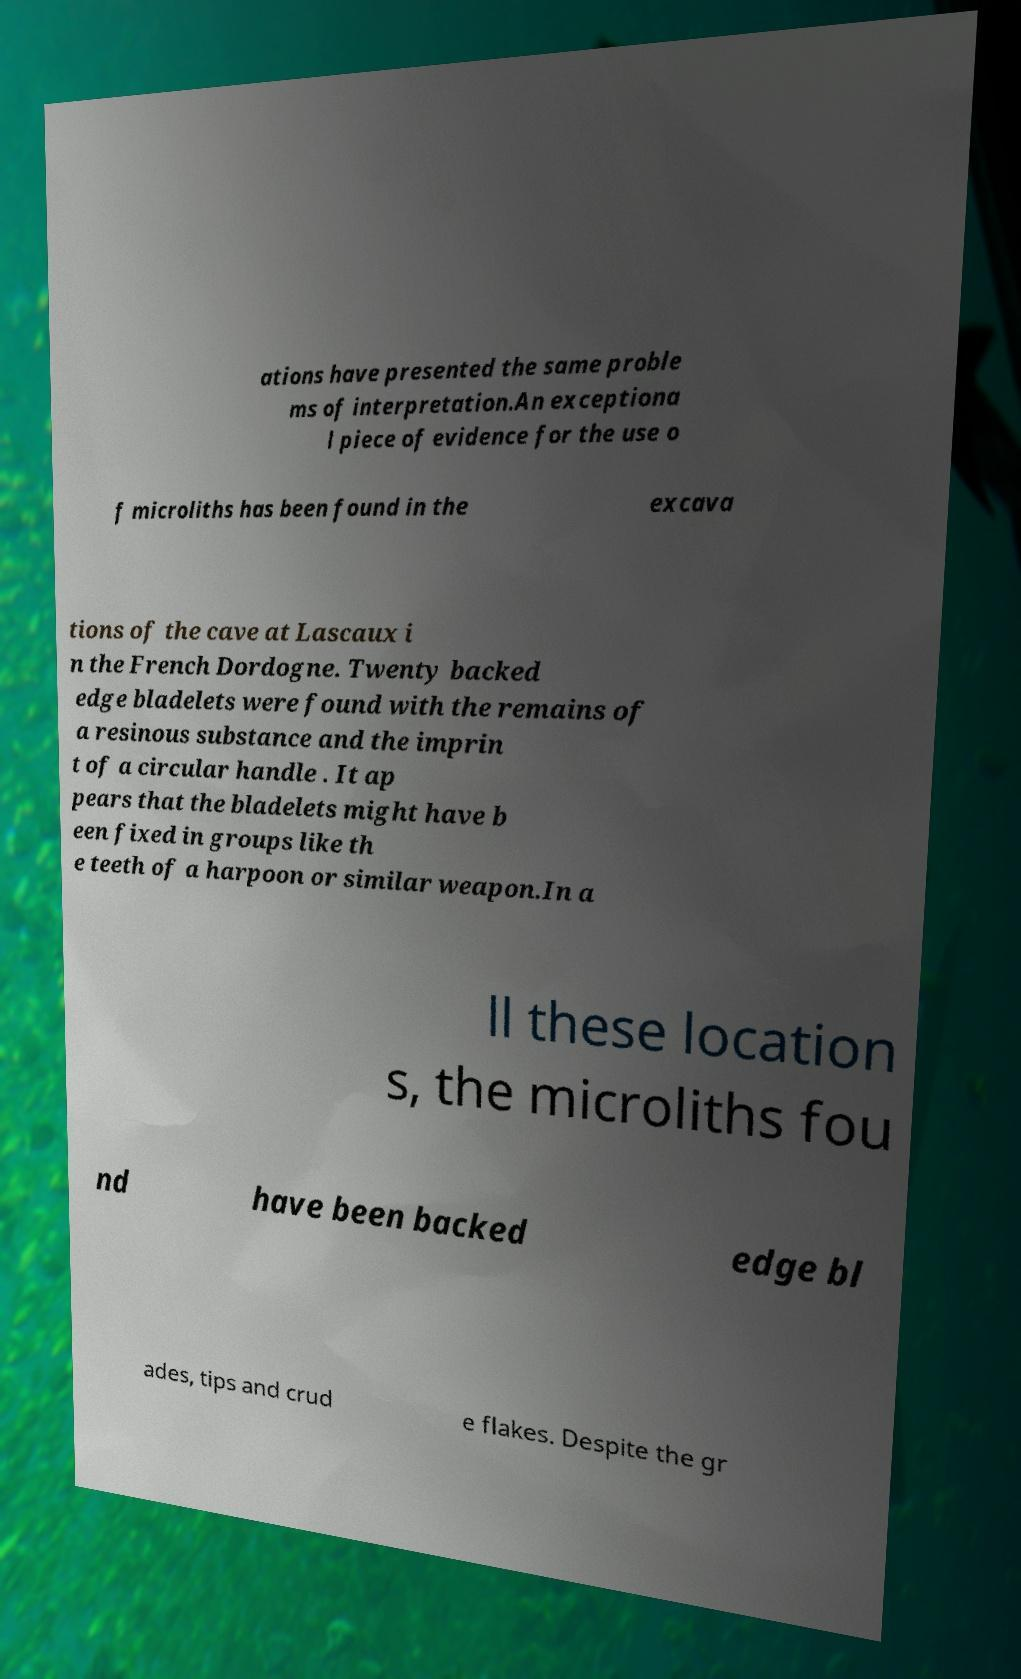What messages or text are displayed in this image? I need them in a readable, typed format. ations have presented the same proble ms of interpretation.An exceptiona l piece of evidence for the use o f microliths has been found in the excava tions of the cave at Lascaux i n the French Dordogne. Twenty backed edge bladelets were found with the remains of a resinous substance and the imprin t of a circular handle . It ap pears that the bladelets might have b een fixed in groups like th e teeth of a harpoon or similar weapon.In a ll these location s, the microliths fou nd have been backed edge bl ades, tips and crud e flakes. Despite the gr 